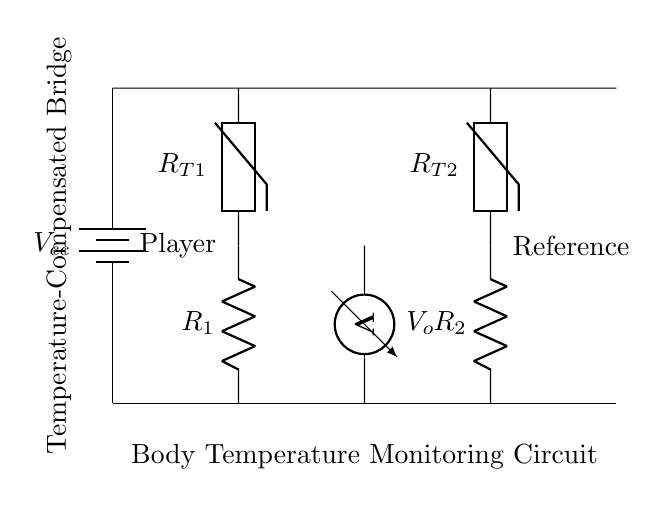What type of circuit is depicted? The circuit is a temperature-compensated bridge, designed to balance the readings from two sensors, making it ideal for precise temperature monitoring.
Answer: temperature-compensated bridge What are the two types of resistive components shown? The circuit contains resistors labeled R1 and R2, along with thermistors labeled R_T1 and R_T2, which vary their resistance based on temperature.
Answer: resistors and thermistors What is the purpose of the voltmeter in this circuit? The voltmeter measures the voltage difference (V_o) across specific points in the bridge, indicating the condition based on the two thermistors assisting in temperature monitoring.
Answer: measure voltage difference Which component represents the player in the circuit? The thermistor R_T1, connected to R1, represents the player's body temperature as it changes resistance with temperature fluctuations.
Answer: R_T1 What does the battery provide to the circuit? The battery (labeled V_cc) provides the necessary electrical power to the circuit components, ensuring they can function and deliver measurements.
Answer: electrical power Why are there two thermistors in the circuit? The two thermistors aid in creating a bridge configuration that compensates for temperature variations, providing a more stable reading than a single sensor setup.
Answer: better stability How is the output voltage related to temperature changes? As the temperature changes, the resistance of the thermistors alters, which then affects the output voltage (V_o) by changing the balance of the bridge circuit, thus indicating temperature variations.
Answer: affected by thermistor resistance 